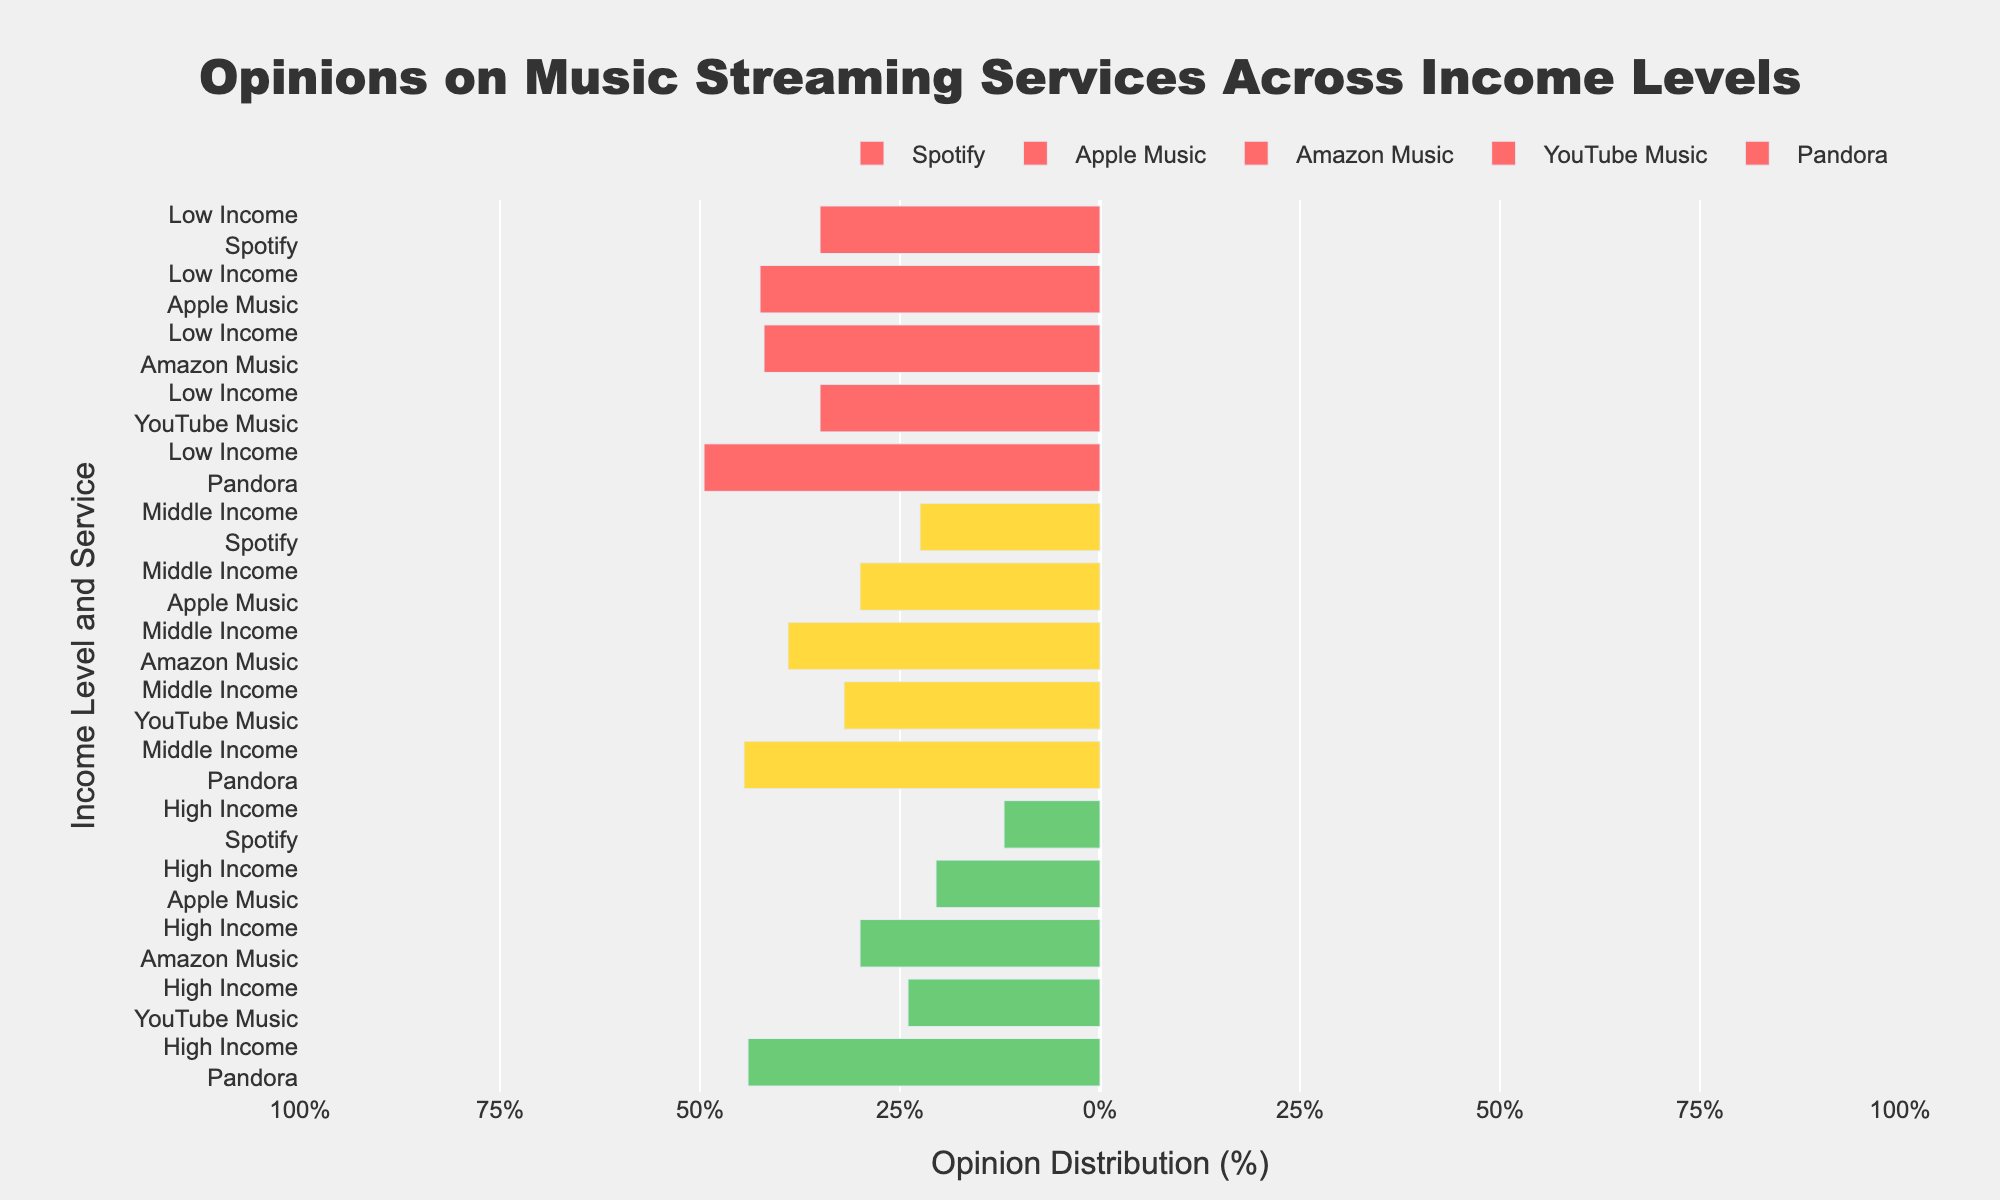Which music streaming service has the highest approval (Approve + Strongly Approve) rating among high-income users? To determine which service high-income users favor, look for the highest percentage on the right side of the high-income category. Spotify has the highest combined Approve and Strongly Approve ratings for high-income users.
Answer: Spotify Comparing middle-income and low-income users, which group has a higher neutral opinion towards YouTube Music? Check the middle section of the bar for YouTube Music in both income groups. Low-income has 30% Neutral, while middle-income has 20% Neutral.
Answer: Low-income users What's the total disapproval (Disapprove + Strongly Disapprove) for Amazon Music among low-income users? Sum up the Disapprove and Strongly Disapprove percentages for Amazon Music in the low-income group: 20 + 8 = 28.
Answer: 28 Which streaming service has the smallest strongly disapprove rating across all income levels? Look for the smallest Strongly Disapprove rating section among all services and all income levels. Spotify among high-income users has a strongly disapprove rating of 2%.
Answer: Spotify (high-income users) How does the approval rating for Pandora among middle-income users compare to that among low-income users? Compare the combined approval (Approve + Strongly Approve) ratings: Middle-income: 23 + 20; Low-income: 20 + 13
Answer: Middle-income has a higher approval rating Which income group shows the highest variability in opinions for Apple Music? Look at the spread of all responses for Apple Music across different income levels. High-income users show a substantial range from strong disapproval to strong approval, indicating high variability.
Answer: High-income users What is the combined neutral and strongly approve opinions for Spotify among high-income users? Sum the Neutral and Strongly Approve ratings for Spotify in the high-income group: 10 + 58 = 68.
Answer: 68 Among low-income users, which streaming service has the highest neutral rating? Check the height of the neutral section in the low-income category. YouTube Music has the highest Neutral with 30%.
Answer: YouTube Music What is the difference in the strongly disapprove rating for Pandora between high-income users and low-income users? Subtract the Strongly Disapprove rating of Pandora for low-income users from that of high-income users: 15 - 10 = 5.
Answer: 5 